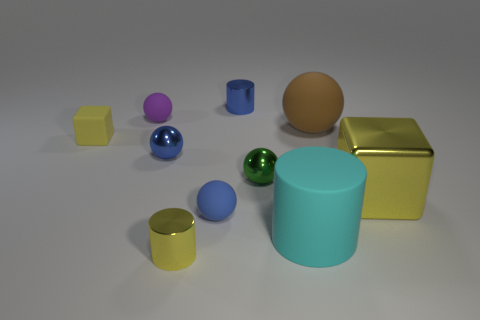The large sphere that is made of the same material as the large cyan cylinder is what color?
Ensure brevity in your answer.  Brown. Does the small yellow thing that is in front of the large cylinder have the same shape as the small metal thing that is behind the small block?
Provide a short and direct response. Yes. What number of matte things are either small cylinders or yellow things?
Offer a terse response. 1. There is a tiny thing that is the same color as the matte cube; what is it made of?
Provide a short and direct response. Metal. Is there anything else that has the same shape as the tiny yellow shiny thing?
Ensure brevity in your answer.  Yes. What is the material of the block that is on the left side of the big cyan rubber object?
Keep it short and to the point. Rubber. Does the small blue ball behind the metallic block have the same material as the large yellow block?
Offer a very short reply. Yes. What number of things are either cyan metal cylinders or yellow cylinders in front of the small rubber cube?
Offer a very short reply. 1. The other yellow thing that is the same shape as the tiny yellow matte object is what size?
Offer a terse response. Large. There is a tiny green sphere; are there any matte cylinders to the left of it?
Your answer should be very brief. No. 